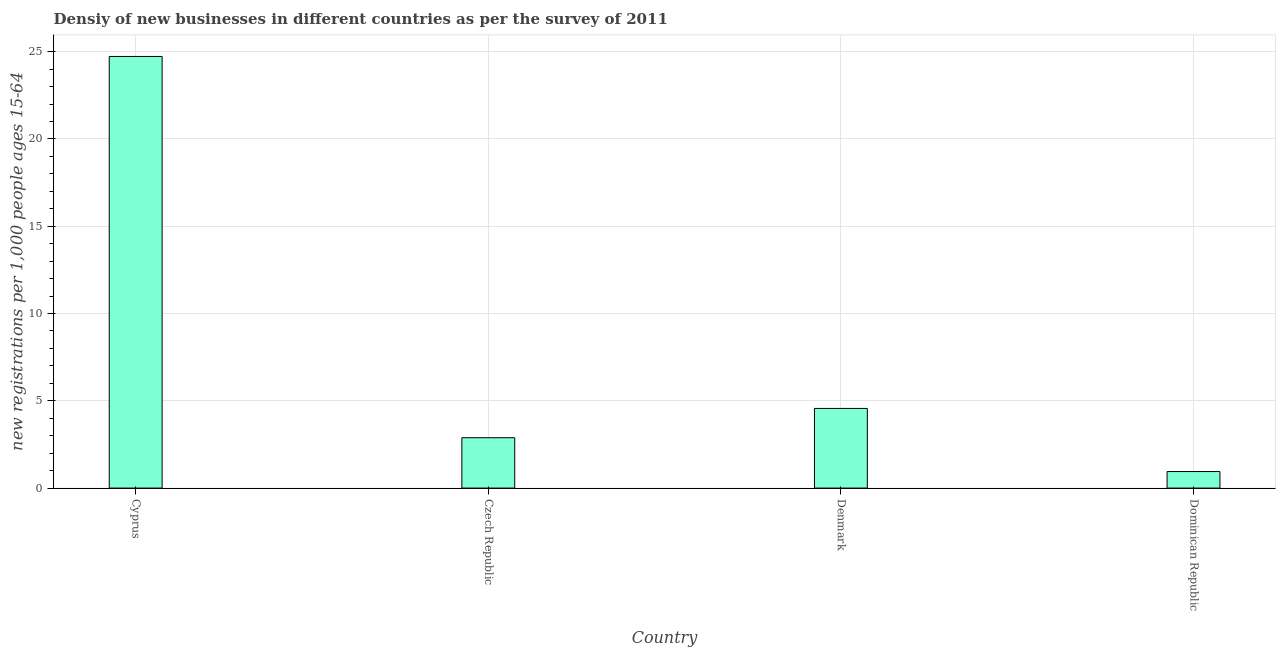What is the title of the graph?
Give a very brief answer. Densiy of new businesses in different countries as per the survey of 2011. What is the label or title of the X-axis?
Keep it short and to the point. Country. What is the label or title of the Y-axis?
Give a very brief answer. New registrations per 1,0 people ages 15-64. What is the density of new business in Denmark?
Your answer should be compact. 4.56. Across all countries, what is the maximum density of new business?
Ensure brevity in your answer.  24.73. Across all countries, what is the minimum density of new business?
Provide a succinct answer. 0.95. In which country was the density of new business maximum?
Provide a short and direct response. Cyprus. In which country was the density of new business minimum?
Offer a terse response. Dominican Republic. What is the sum of the density of new business?
Ensure brevity in your answer.  33.12. What is the difference between the density of new business in Cyprus and Dominican Republic?
Provide a succinct answer. 23.78. What is the average density of new business per country?
Offer a terse response. 8.28. What is the median density of new business?
Offer a terse response. 3.72. What is the ratio of the density of new business in Cyprus to that in Dominican Republic?
Provide a succinct answer. 26.07. Is the difference between the density of new business in Cyprus and Dominican Republic greater than the difference between any two countries?
Your response must be concise. Yes. What is the difference between the highest and the second highest density of new business?
Ensure brevity in your answer.  20.16. What is the difference between the highest and the lowest density of new business?
Give a very brief answer. 23.78. Are all the bars in the graph horizontal?
Give a very brief answer. No. How many countries are there in the graph?
Make the answer very short. 4. What is the difference between two consecutive major ticks on the Y-axis?
Offer a terse response. 5. What is the new registrations per 1,000 people ages 15-64 of Cyprus?
Your response must be concise. 24.73. What is the new registrations per 1,000 people ages 15-64 of Czech Republic?
Give a very brief answer. 2.89. What is the new registrations per 1,000 people ages 15-64 in Denmark?
Provide a short and direct response. 4.56. What is the new registrations per 1,000 people ages 15-64 in Dominican Republic?
Make the answer very short. 0.95. What is the difference between the new registrations per 1,000 people ages 15-64 in Cyprus and Czech Republic?
Ensure brevity in your answer.  21.84. What is the difference between the new registrations per 1,000 people ages 15-64 in Cyprus and Denmark?
Provide a succinct answer. 20.16. What is the difference between the new registrations per 1,000 people ages 15-64 in Cyprus and Dominican Republic?
Ensure brevity in your answer.  23.78. What is the difference between the new registrations per 1,000 people ages 15-64 in Czech Republic and Denmark?
Make the answer very short. -1.68. What is the difference between the new registrations per 1,000 people ages 15-64 in Czech Republic and Dominican Republic?
Provide a short and direct response. 1.94. What is the difference between the new registrations per 1,000 people ages 15-64 in Denmark and Dominican Republic?
Your answer should be very brief. 3.61. What is the ratio of the new registrations per 1,000 people ages 15-64 in Cyprus to that in Czech Republic?
Ensure brevity in your answer.  8.57. What is the ratio of the new registrations per 1,000 people ages 15-64 in Cyprus to that in Denmark?
Provide a short and direct response. 5.42. What is the ratio of the new registrations per 1,000 people ages 15-64 in Cyprus to that in Dominican Republic?
Offer a very short reply. 26.07. What is the ratio of the new registrations per 1,000 people ages 15-64 in Czech Republic to that in Denmark?
Keep it short and to the point. 0.63. What is the ratio of the new registrations per 1,000 people ages 15-64 in Czech Republic to that in Dominican Republic?
Offer a terse response. 3.04. What is the ratio of the new registrations per 1,000 people ages 15-64 in Denmark to that in Dominican Republic?
Your response must be concise. 4.81. 